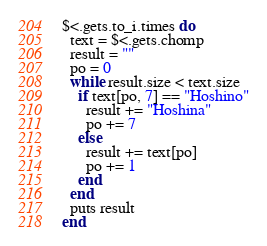<code> <loc_0><loc_0><loc_500><loc_500><_Ruby_>$<.gets.to_i.times do
  text = $<.gets.chomp
  result = ""
  po = 0
  while result.size < text.size
    if text[po, 7] == "Hoshino"
      result += "Hoshina"
      po += 7
    else
      result += text[po]
      po += 1
    end
  end
  puts result
end
</code> 